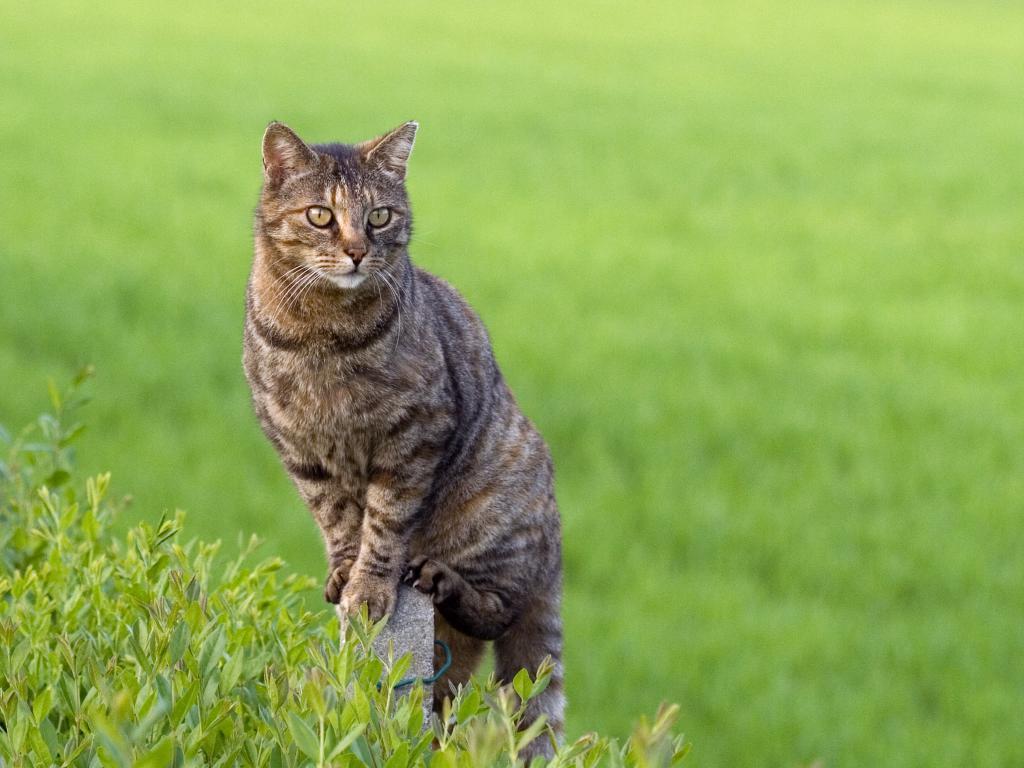Can you describe this image briefly? In this image there is a cat standing on a rock. Left bottom there are few plants having leaves. Background is blurry. 